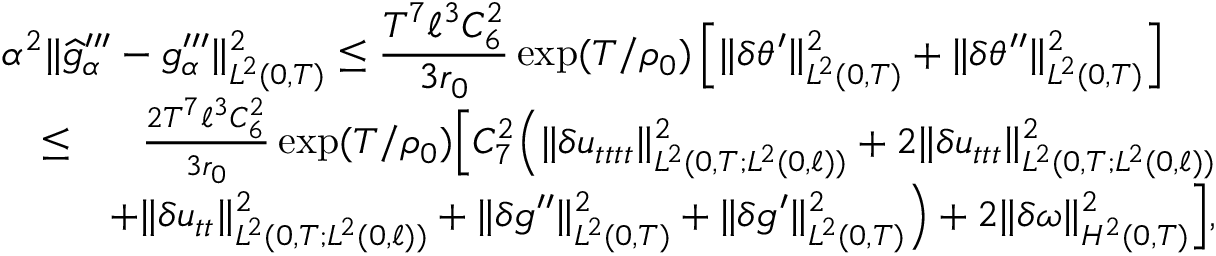<formula> <loc_0><loc_0><loc_500><loc_500>\begin{array} { r l r } { { \alpha ^ { 2 } \| \widehat { g } _ { \alpha } ^ { \prime \prime \prime } - g _ { \alpha } ^ { \prime \prime \prime } \| _ { L ^ { 2 } ( 0 , T ) } ^ { 2 } \leq \frac { T ^ { 7 } \ell ^ { 3 } C _ { 6 } ^ { 2 } } { 3 r _ { 0 } } \exp ( T / \rho _ { 0 } ) \left [ \| \delta \theta ^ { \prime } \| _ { L ^ { 2 } ( 0 , T ) } ^ { 2 } + \| \delta \theta ^ { \prime \prime } \| _ { L ^ { 2 } ( 0 , T ) } ^ { 2 } \right ] } } \\ & { \leq } & { \frac { 2 T ^ { 7 } \ell ^ { 3 } C _ { 6 } ^ { 2 } } { 3 r _ { 0 } } \exp ( T / \rho _ { 0 } ) \left [ C _ { 7 } ^ { 2 } \left ( \| \delta u _ { t t t t } \| _ { L ^ { 2 } ( 0 , T ; L ^ { 2 } ( 0 , \ell ) ) } ^ { 2 } + 2 \| \delta u _ { t t t } \| _ { L ^ { 2 } ( 0 , T ; L ^ { 2 } ( 0 , \ell ) ) } ^ { 2 } } \\ & { + \| \delta u _ { t t } \| _ { L ^ { 2 } ( 0 , T ; L ^ { 2 } ( 0 , \ell ) ) } ^ { 2 } + \| \delta g ^ { \prime \prime } \| _ { L ^ { 2 } ( 0 , T ) } ^ { 2 } + \| \delta g ^ { \prime } \| _ { L ^ { 2 } ( 0 , T ) } ^ { 2 } \right ) + 2 \| \delta \omega \| _ { H ^ { 2 } ( 0 , T ) } ^ { 2 } \right ] , } \end{array}</formula> 